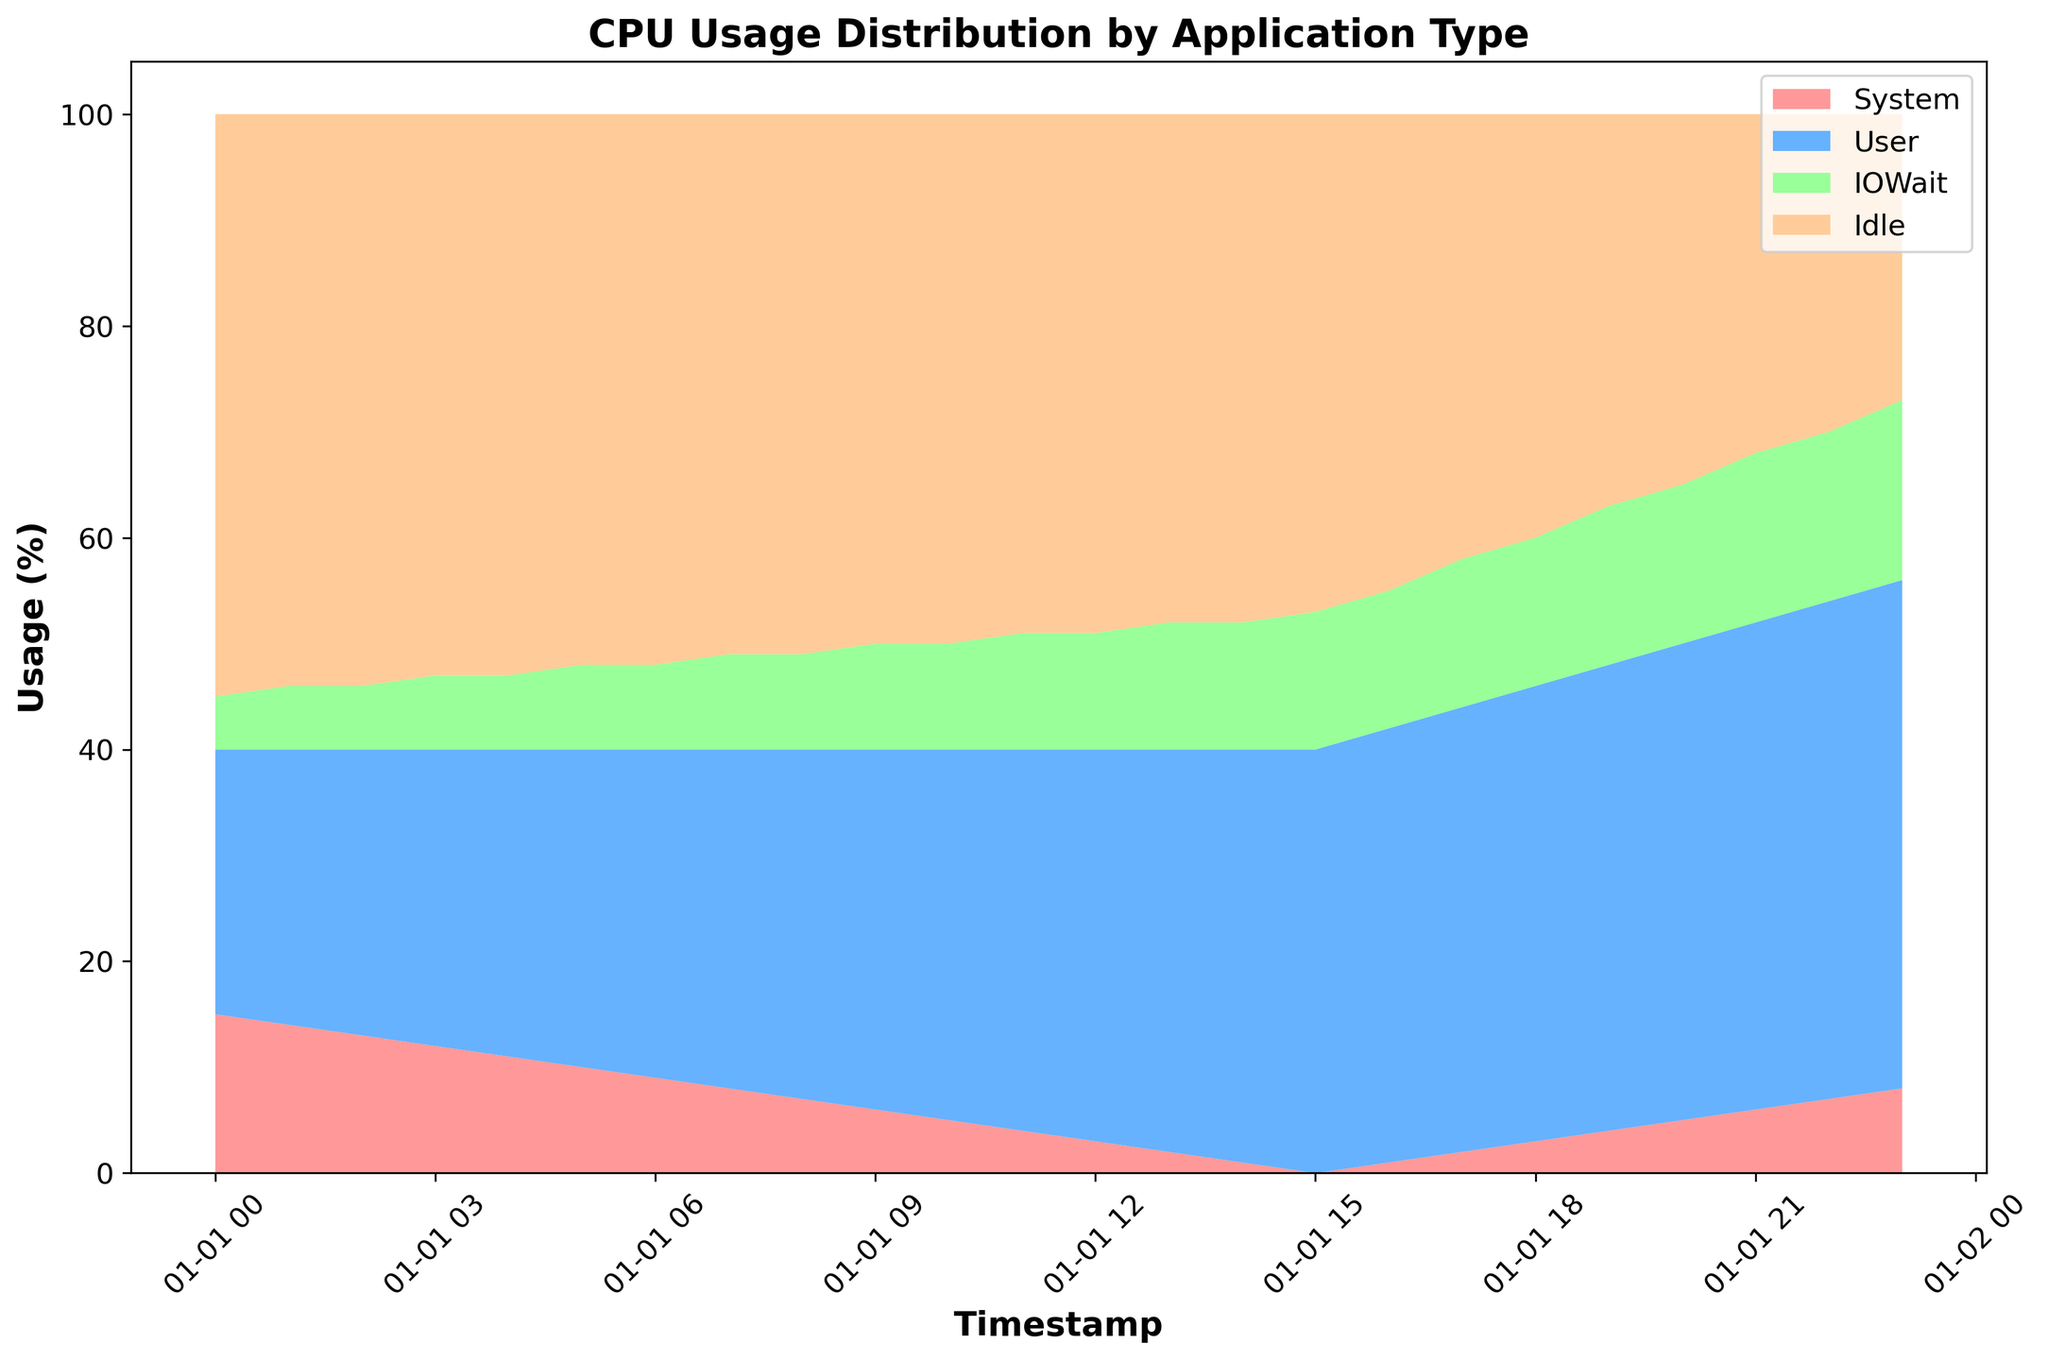What's the general trend of the 'System' CPU usage over time? Observing the time series data of the 'System' usage, it starts at 15% and gradually decreases to 0 by 15:00, then slightly rises and stabilizes between 1% to 8% by the end of the day.
Answer: Decreasing Between which two timestamps was the 'User' CPU usage the most stable? Comparing the 'User' usage values at each timestamp, the usage increases at a consistent rate, showing the smallest change between 10:00 and 12:00 where it only increases by 1% each hour.
Answer: 10:00 and 12:00 What is the cumulative percentage of 'IOWait' and 'System' CPU usage at 17:00? At 17:00, 'IOWait' is at 14% and 'System' is at 2%. Adding these values, the cumulative percentage is 14 + 2 = 16%.
Answer: 16% Which time of day has the highest 'Idle' CPU usage? The 'Idle' CPU usage starts at 55% at 00:00 and generally decreases over time. The highest usage is at 00:00.
Answer: 00:00 During which hour does 'User' CPU usage first equal or surpass 'System' CPU usage? In the initial hours, 'System' CPU usage is greater than 'User'. However, at 05:00, 'User' (30%) surpasses 'System' (10%).
Answer: 05:00 Is there a point in time where the CPU is mostly 'Idle'? The 'Idle' category has the highest percentage at all timestamps. At the start (00:00), 'Idle' has the highest value of 55%, which is predominantly idle state.
Answer: Yes, at 00:00 By how much does 'User' CPU usage increase between 06:00 and 12:00? 'User' usage at 06:00 is 31%, and at 12:00 it is 37%. The increase is 37% - 31% = 6%.
Answer: 6% How does the 'IOWait' CPU usage change over the 24-hour period? The 'IOWait' usage starts at 5% at 00:00 and gradually increases throughout the day to reach 17% at 23:00.
Answer: Increasing What is the combined 'System' and 'User' CPU usage at 09:00? At 09:00, 'System' is at 6% and 'User' is at 34%. The combined value is 6 + 34 = 40%.
Answer: 40% 